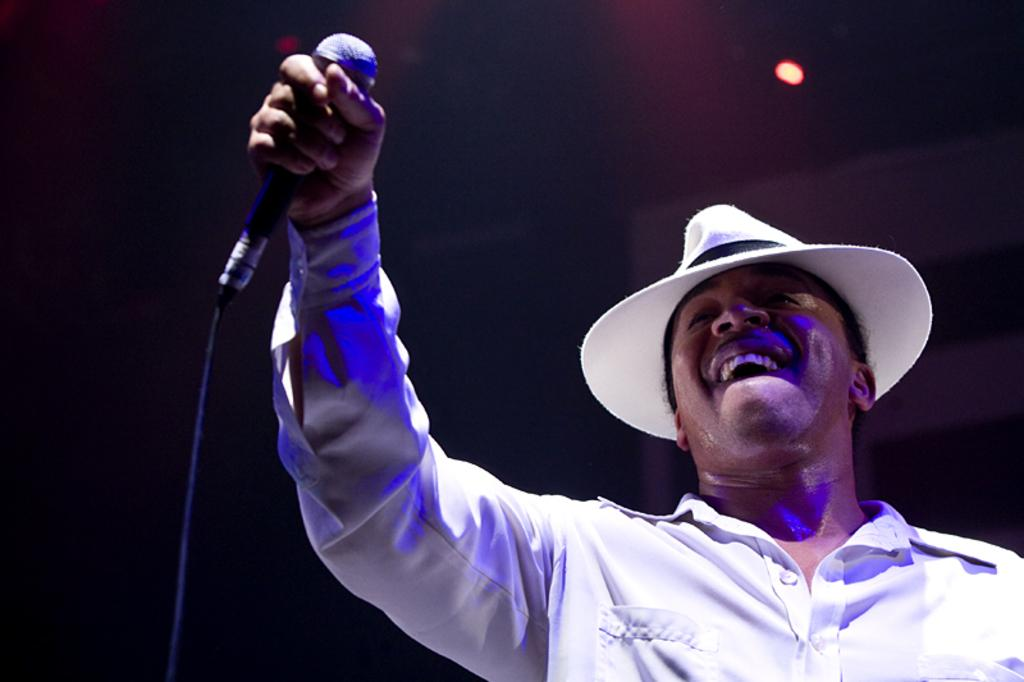Who is the main subject in the image? There is a man in the image. What is the man wearing? The man is wearing a white shirt and a white hat. What is the man holding in the image? The man is holding a mic. What is the man's facial expression in the image? The man is smiling. What type of car can be seen in the background of the image? There is no car present in the image. Can you tell me how many pigs are visible in the image? There are no pigs present in the image. 